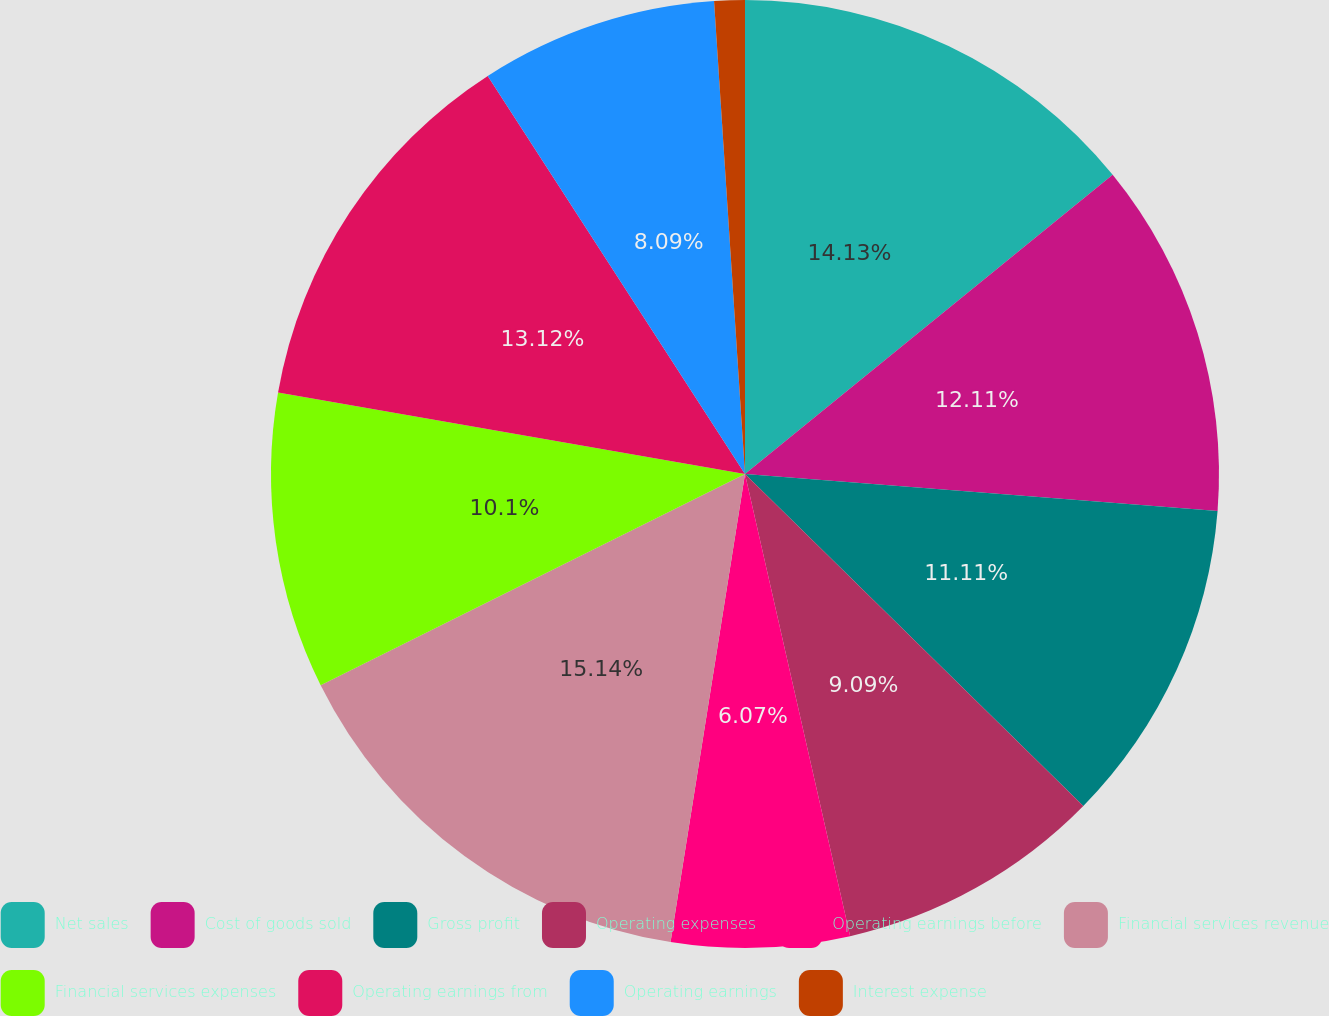Convert chart to OTSL. <chart><loc_0><loc_0><loc_500><loc_500><pie_chart><fcel>Net sales<fcel>Cost of goods sold<fcel>Gross profit<fcel>Operating expenses<fcel>Operating earnings before<fcel>Financial services revenue<fcel>Financial services expenses<fcel>Operating earnings from<fcel>Operating earnings<fcel>Interest expense<nl><fcel>14.13%<fcel>12.11%<fcel>11.11%<fcel>9.09%<fcel>6.07%<fcel>15.14%<fcel>10.1%<fcel>13.12%<fcel>8.09%<fcel>1.04%<nl></chart> 